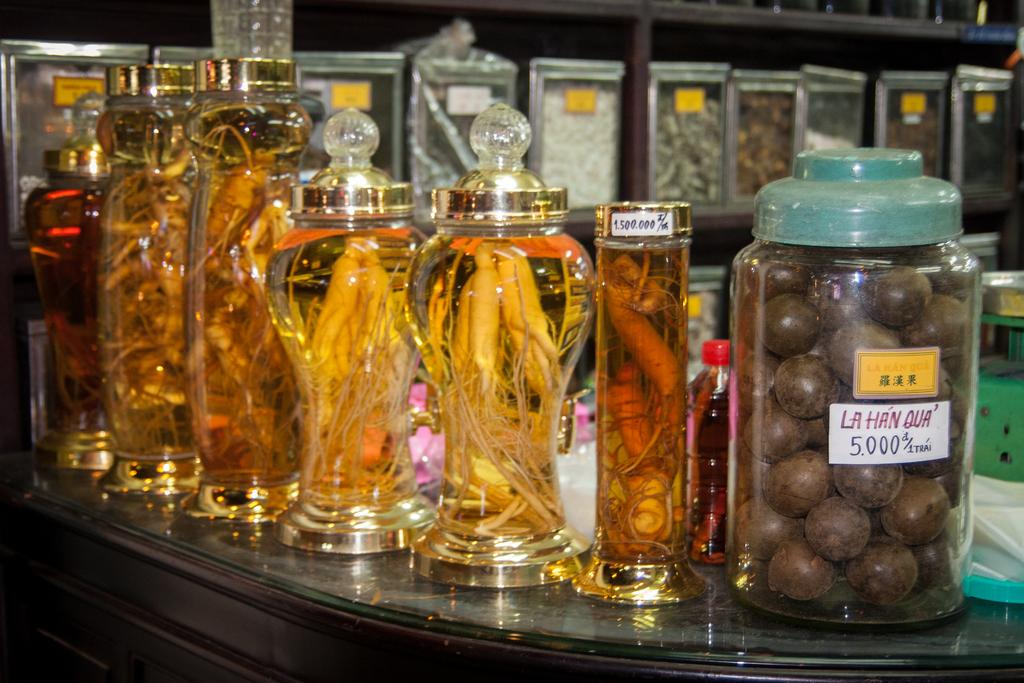<image>
Describe the image concisely. Glass jars display many different things on a counter, including something that looks like chocolate balls and says La Han Qua. 